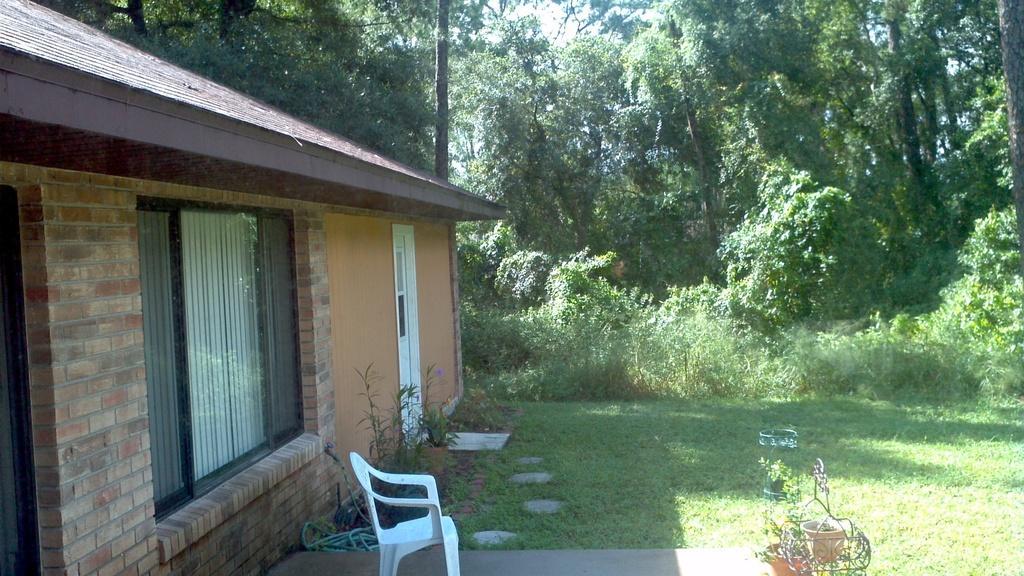Please provide a concise description of this image. In this image we can see a house with glass windows, doors and some other objects. In front of the house there are some plants, grass and other objects. At the bottom of the image there is a chair, floor and plants. On the right side of the image there is the grass. In the background of the image there are some trees, plants and the sky. 